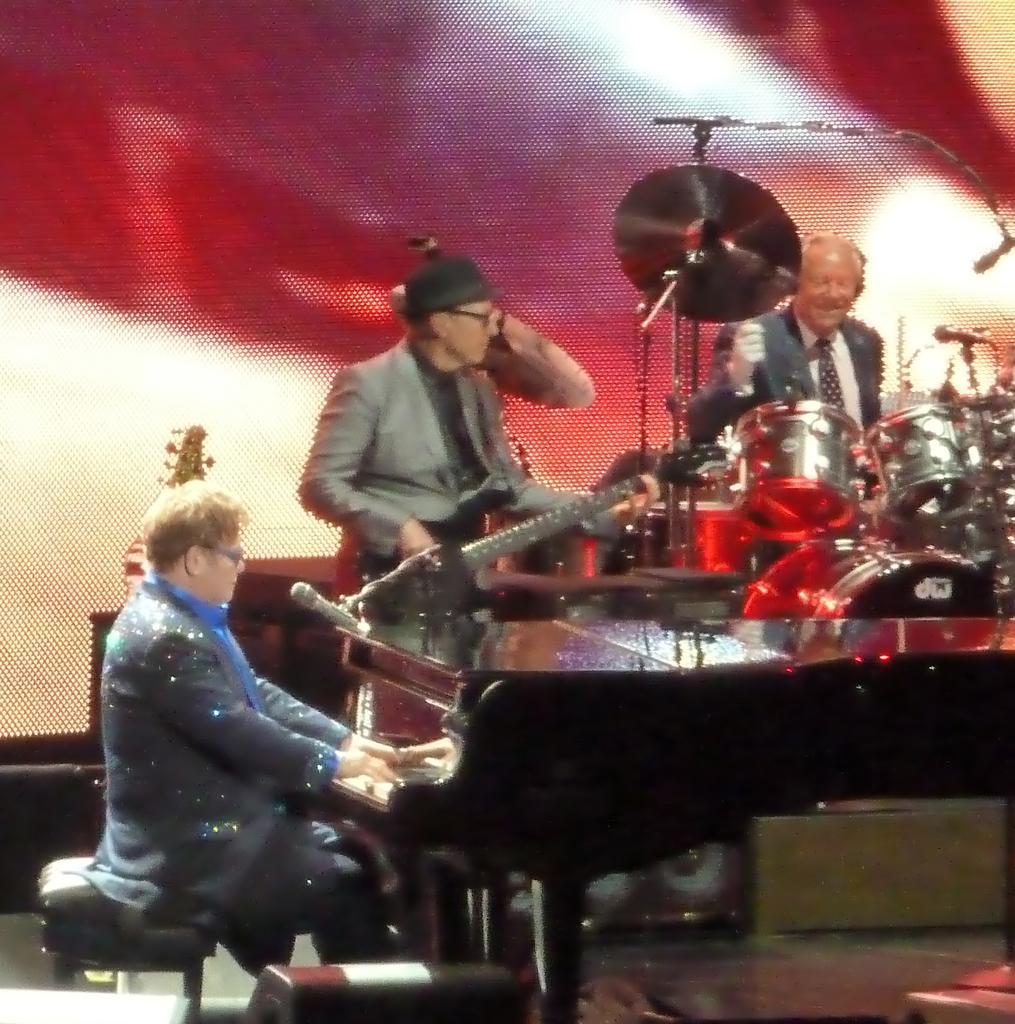How would you summarize this image in a sentence or two? In this image we can see people playing musical instruments. In the background there is a screen and we can see mics placed on the stands. 